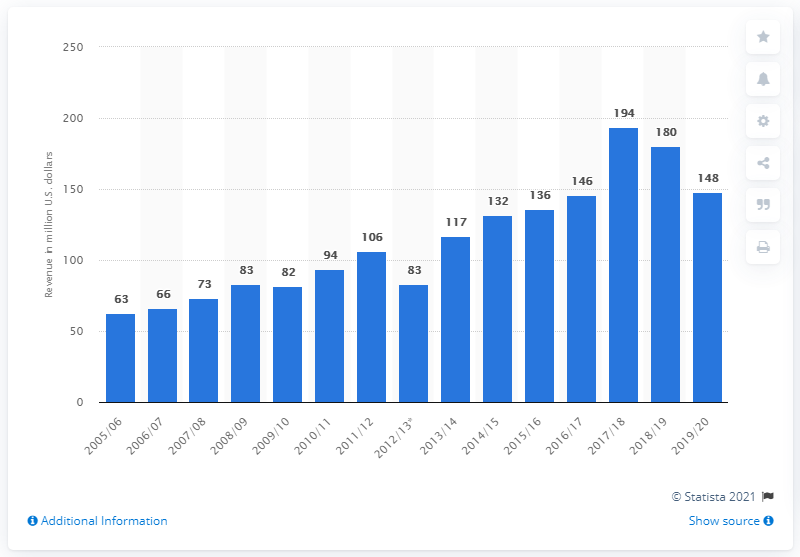List a handful of essential elements in this visual. The Washington Capitals earned a significant amount of money during the 2019/20 season, reaching 148 million dollars in total revenue. 